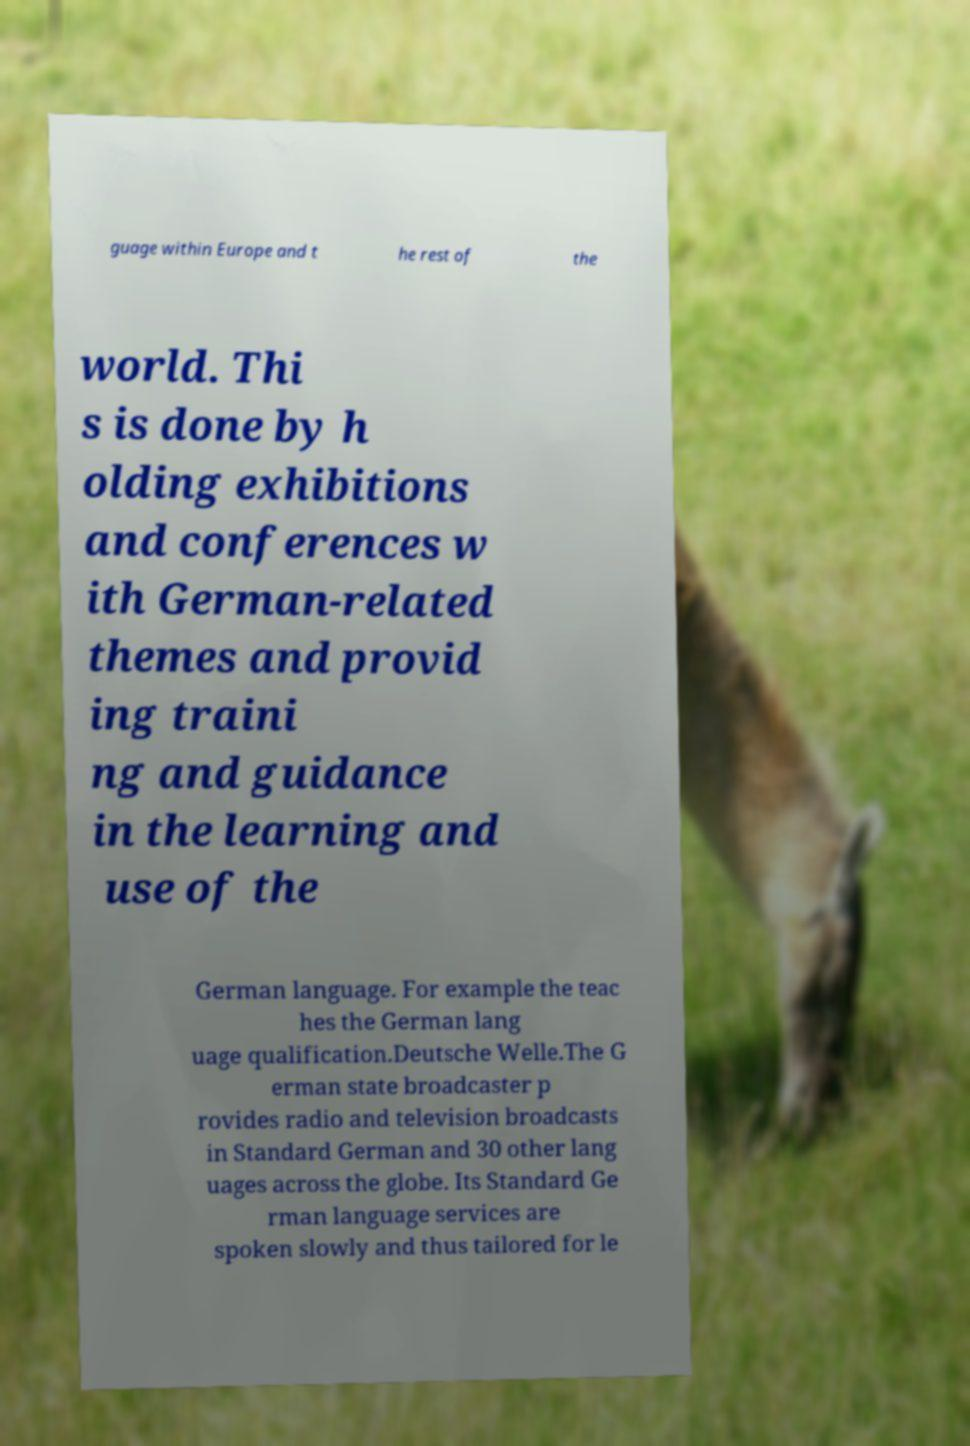Could you assist in decoding the text presented in this image and type it out clearly? guage within Europe and t he rest of the world. Thi s is done by h olding exhibitions and conferences w ith German-related themes and provid ing traini ng and guidance in the learning and use of the German language. For example the teac hes the German lang uage qualification.Deutsche Welle.The G erman state broadcaster p rovides radio and television broadcasts in Standard German and 30 other lang uages across the globe. Its Standard Ge rman language services are spoken slowly and thus tailored for le 